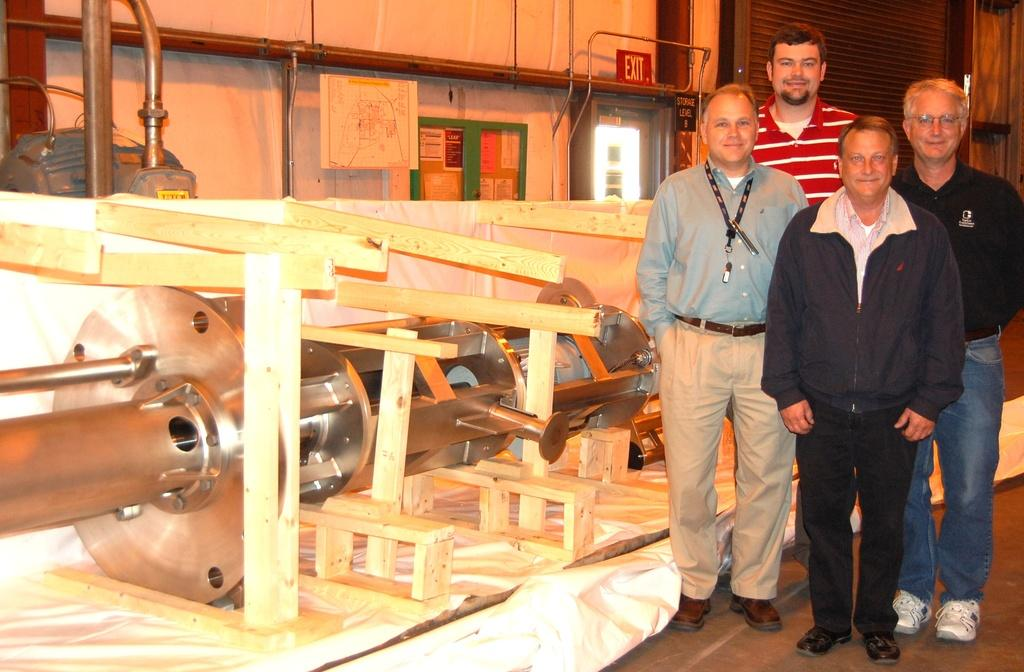How many people are present in the image? There are four men standing in the image. What can be seen beside the men? There are mechanical machines beside the men. What type of neck accessory is worn by the men in the image? There is no information about neck accessories in the image, as the focus is on the men and the mechanical machines. 